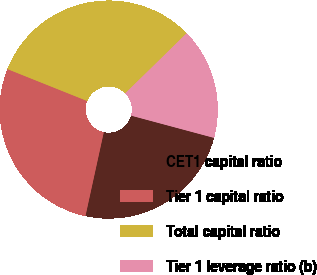<chart> <loc_0><loc_0><loc_500><loc_500><pie_chart><fcel>CET1 capital ratio<fcel>Tier 1 capital ratio<fcel>Total capital ratio<fcel>Tier 1 leverage ratio (b)<nl><fcel>24.25%<fcel>27.63%<fcel>31.61%<fcel>16.5%<nl></chart> 